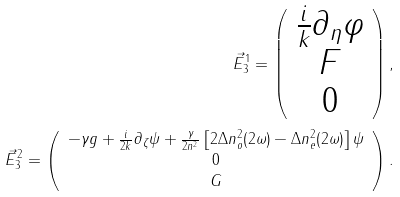<formula> <loc_0><loc_0><loc_500><loc_500>\vec { E } _ { 3 } ^ { 1 } = \left ( \begin{array} { c } \frac { i } { k } \partial _ { \eta } \varphi \\ F \\ 0 \end{array} \right ) , \\ \vec { E } _ { 3 } ^ { 2 } = \left ( \begin{array} { c } - \gamma g + \frac { i } { 2 k } \partial _ { \zeta } \psi + \frac { \gamma } { 2 n ^ { 2 } } \left [ 2 \Delta n _ { o } ^ { 2 } ( 2 \omega ) - \Delta n _ { e } ^ { 2 } ( 2 \omega ) \right ] \psi \\ 0 \\ G \end{array} \right ) .</formula> 